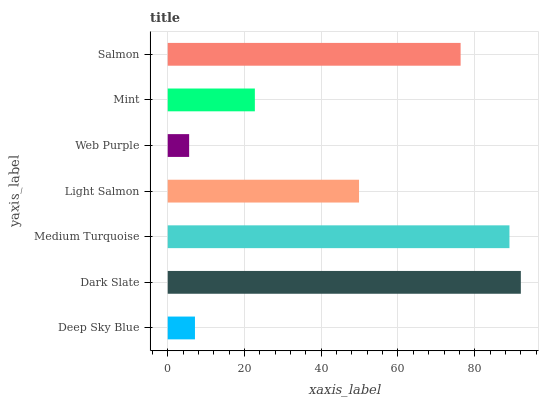Is Web Purple the minimum?
Answer yes or no. Yes. Is Dark Slate the maximum?
Answer yes or no. Yes. Is Medium Turquoise the minimum?
Answer yes or no. No. Is Medium Turquoise the maximum?
Answer yes or no. No. Is Dark Slate greater than Medium Turquoise?
Answer yes or no. Yes. Is Medium Turquoise less than Dark Slate?
Answer yes or no. Yes. Is Medium Turquoise greater than Dark Slate?
Answer yes or no. No. Is Dark Slate less than Medium Turquoise?
Answer yes or no. No. Is Light Salmon the high median?
Answer yes or no. Yes. Is Light Salmon the low median?
Answer yes or no. Yes. Is Web Purple the high median?
Answer yes or no. No. Is Mint the low median?
Answer yes or no. No. 